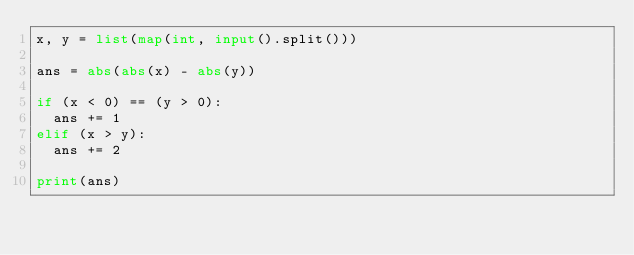Convert code to text. <code><loc_0><loc_0><loc_500><loc_500><_Python_>x, y = list(map(int, input().split()))

ans = abs(abs(x) - abs(y))

if (x < 0) == (y > 0):
  ans += 1
elif (x > y):
  ans += 2

print(ans)</code> 